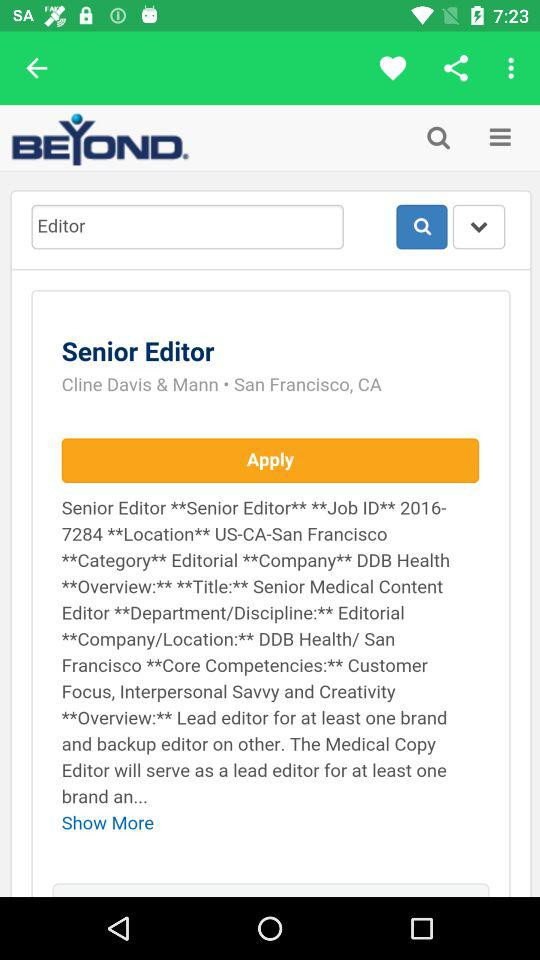Which post can be applied for? The post that can be applied for is senior editor. 